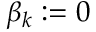Convert formula to latex. <formula><loc_0><loc_0><loc_500><loc_500>\beta _ { k } \colon = 0</formula> 